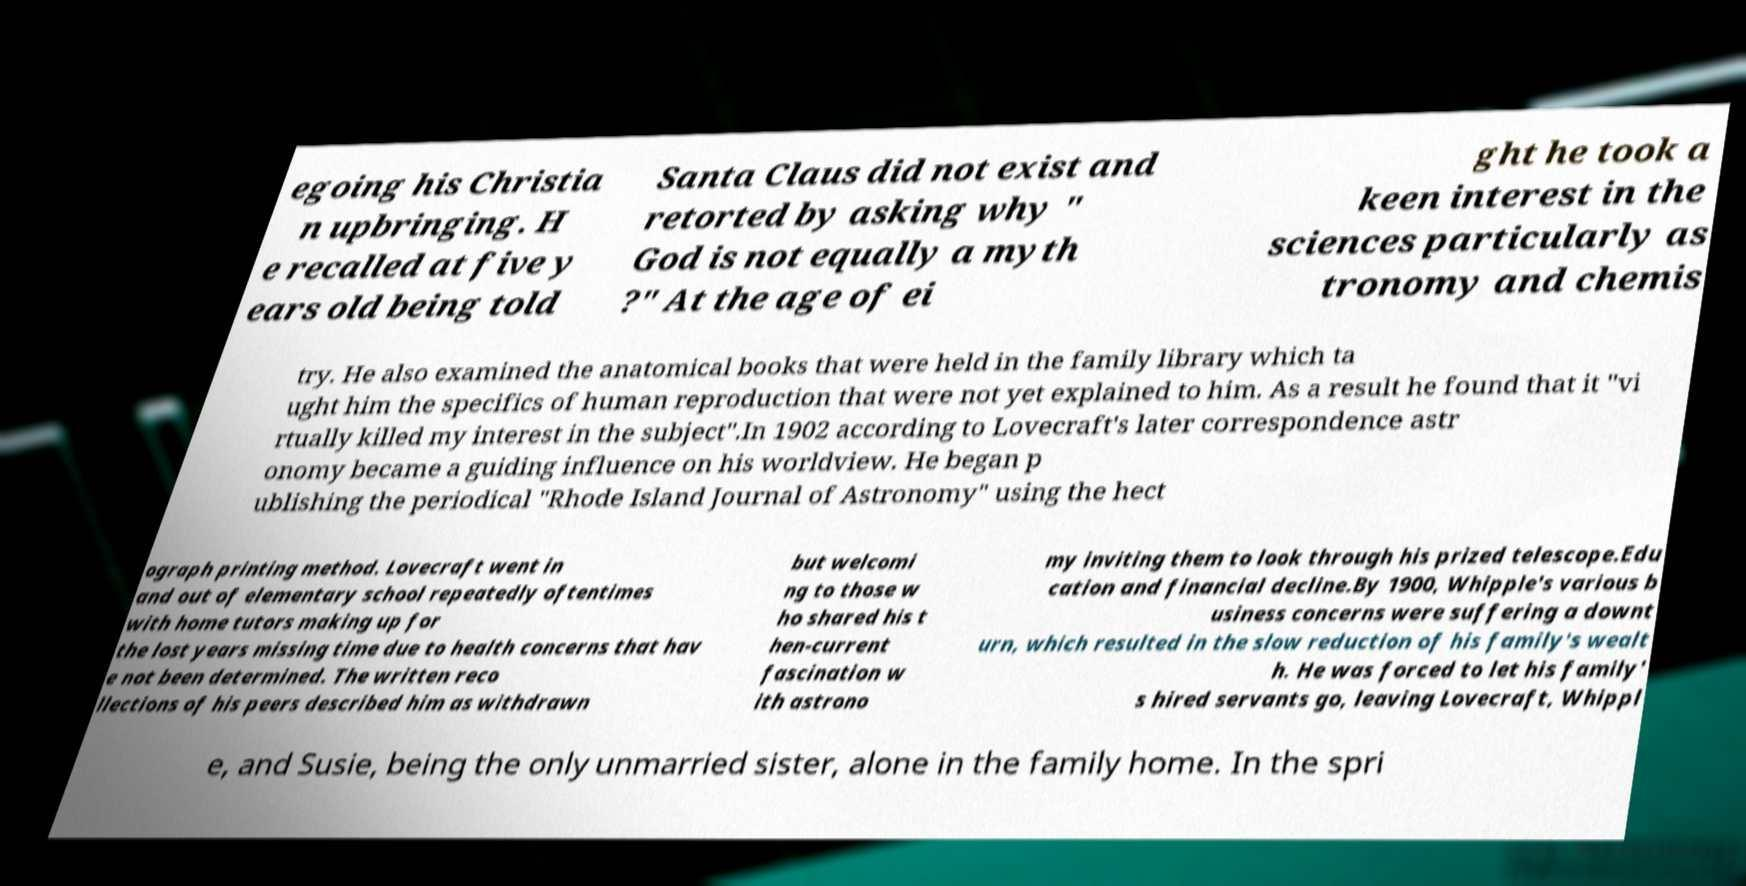I need the written content from this picture converted into text. Can you do that? egoing his Christia n upbringing. H e recalled at five y ears old being told Santa Claus did not exist and retorted by asking why " God is not equally a myth ?" At the age of ei ght he took a keen interest in the sciences particularly as tronomy and chemis try. He also examined the anatomical books that were held in the family library which ta ught him the specifics of human reproduction that were not yet explained to him. As a result he found that it "vi rtually killed my interest in the subject".In 1902 according to Lovecraft's later correspondence astr onomy became a guiding influence on his worldview. He began p ublishing the periodical "Rhode Island Journal of Astronomy" using the hect ograph printing method. Lovecraft went in and out of elementary school repeatedly oftentimes with home tutors making up for the lost years missing time due to health concerns that hav e not been determined. The written reco llections of his peers described him as withdrawn but welcomi ng to those w ho shared his t hen-current fascination w ith astrono my inviting them to look through his prized telescope.Edu cation and financial decline.By 1900, Whipple's various b usiness concerns were suffering a downt urn, which resulted in the slow reduction of his family's wealt h. He was forced to let his family' s hired servants go, leaving Lovecraft, Whippl e, and Susie, being the only unmarried sister, alone in the family home. In the spri 